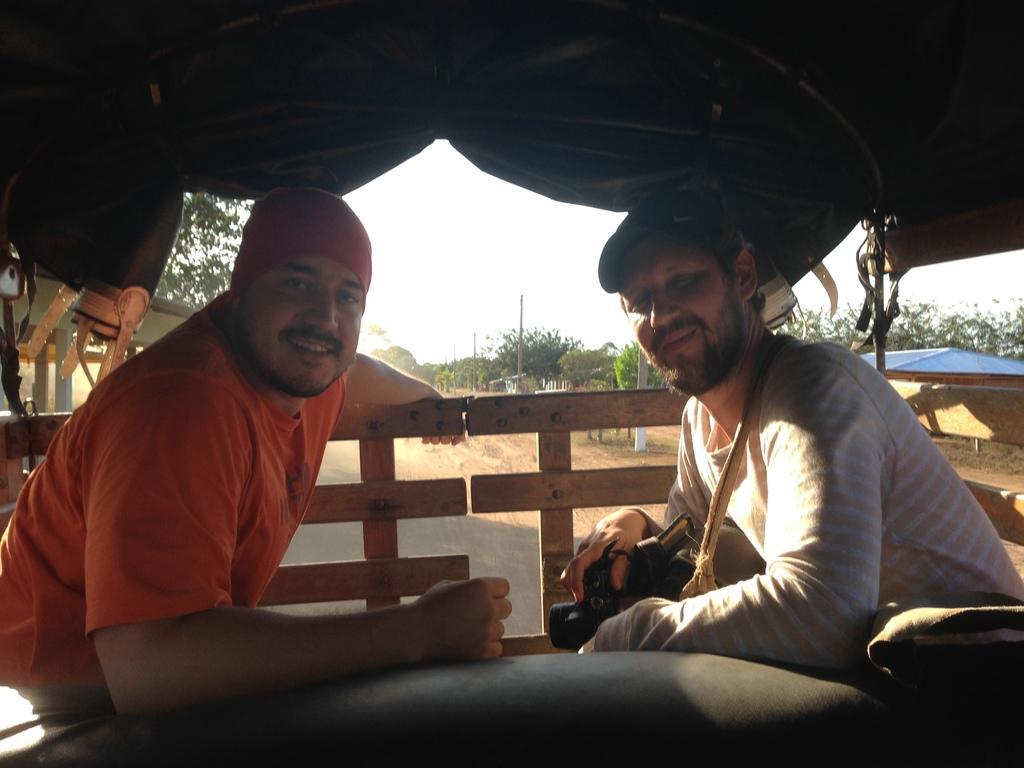In one or two sentences, can you explain what this image depicts? In this image we can see two persons and they are smiling. Here we can see a fence, tent, sheds, road, trees, and poles. In the background there is sky. 